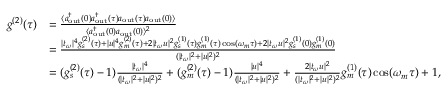<formula> <loc_0><loc_0><loc_500><loc_500>\begin{array} { r l } { g ^ { ( 2 ) } ( \tau ) } & { = \frac { \langle a _ { o u t } ^ { \dag } ( 0 ) a _ { o u t } ^ { \dag } ( \tau ) a _ { o u t } ( \tau ) a _ { o u t } ( 0 ) \rangle } { \langle a _ { o u t } ^ { \dag } ( 0 ) a _ { o u t } ( 0 ) \rangle ^ { 2 } } } \\ & { = \frac { | t _ { \omega } | ^ { 4 } g _ { s } ^ { ( 2 ) } ( \tau ) + | u | ^ { 4 } g _ { m } ^ { ( 2 ) } ( \tau ) + 2 | t _ { \omega } u | ^ { 2 } g _ { s } ^ { ( 1 ) } ( \tau ) g _ { m } ^ { ( 1 ) } ( \tau ) \cos ( \omega _ { m } \tau ) + 2 | t _ { \omega } u | ^ { 2 } g _ { s } ^ { ( 1 ) } ( 0 ) g _ { m } ^ { ( 1 ) } ( 0 ) } { ( | t _ { \omega } | ^ { 2 } + | u | ^ { 2 } ) ^ { 2 } } } \\ & { = ( g _ { s } ^ { ( 2 ) } ( \tau ) - 1 ) \frac { | t _ { \omega } | ^ { 4 } } { ( | t _ { \omega } | ^ { 2 } + | u | ^ { 2 } ) ^ { 2 } } + ( g _ { m } ^ { ( 2 ) } ( \tau ) - 1 ) \frac { | u | ^ { 4 } } { ( | t _ { \omega } | ^ { 2 } + | u | ^ { 2 } ) ^ { 2 } } + \frac { 2 | t _ { \omega } u | ^ { 2 } } { ( | t _ { \omega } | ^ { 2 } + | u | ^ { 2 } ) ^ { 2 } } g _ { m } ^ { ( 1 ) } ( \tau ) \cos ( \omega _ { m } \tau ) + 1 , } \end{array}</formula> 